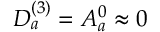Convert formula to latex. <formula><loc_0><loc_0><loc_500><loc_500>D _ { a } ^ { ( 3 ) } = A _ { a } ^ { 0 } \approx 0</formula> 